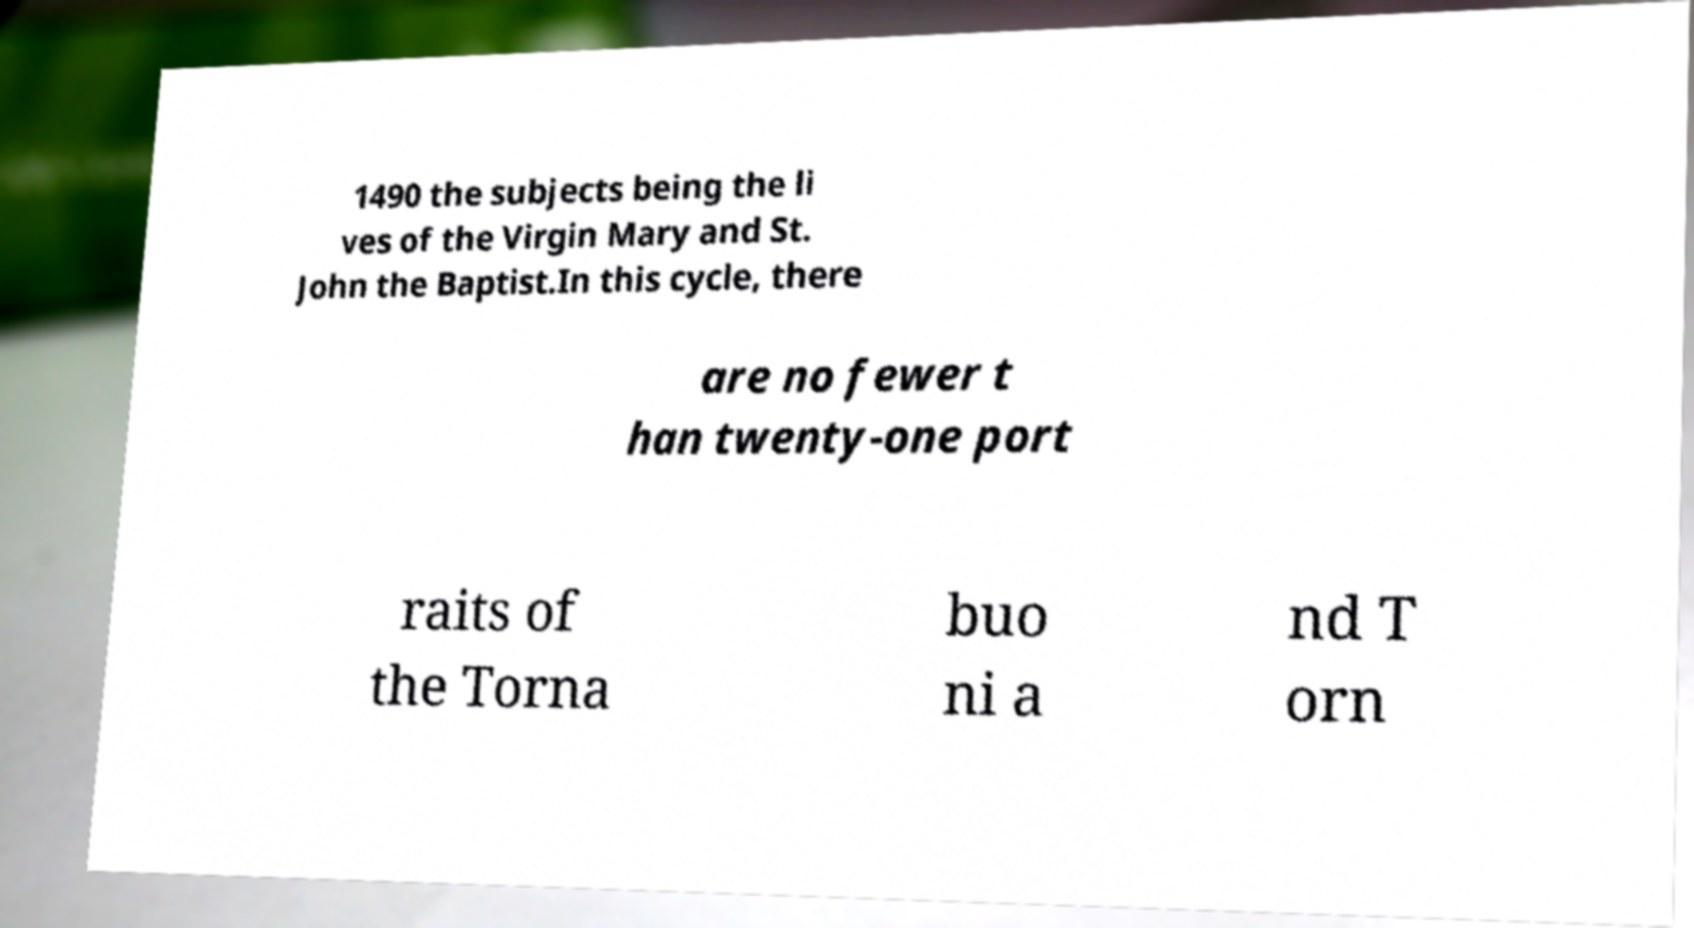For documentation purposes, I need the text within this image transcribed. Could you provide that? 1490 the subjects being the li ves of the Virgin Mary and St. John the Baptist.In this cycle, there are no fewer t han twenty-one port raits of the Torna buo ni a nd T orn 